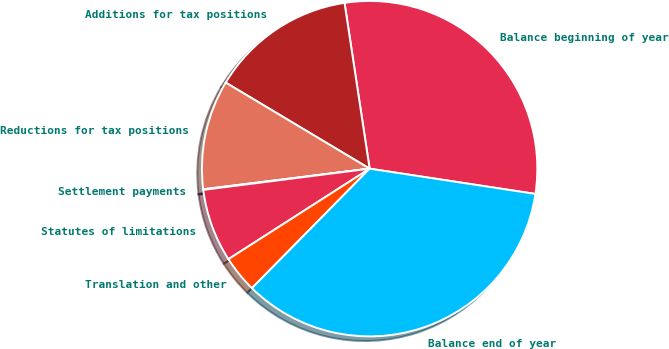<chart> <loc_0><loc_0><loc_500><loc_500><pie_chart><fcel>Balance beginning of year<fcel>Additions for tax positions<fcel>Reductions for tax positions<fcel>Settlement payments<fcel>Statutes of limitations<fcel>Translation and other<fcel>Balance end of year<nl><fcel>29.8%<fcel>14.03%<fcel>10.54%<fcel>0.06%<fcel>7.05%<fcel>3.55%<fcel>34.97%<nl></chart> 